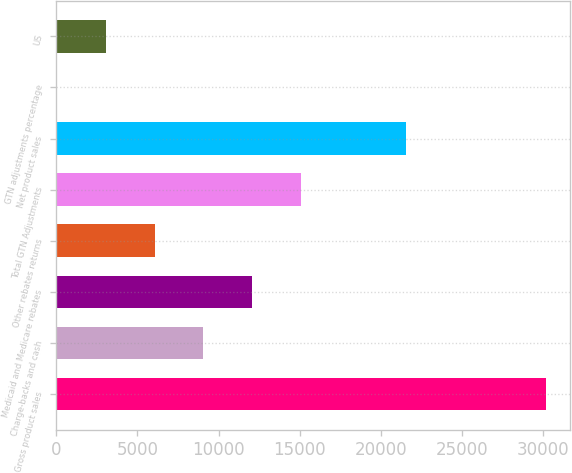Convert chart. <chart><loc_0><loc_0><loc_500><loc_500><bar_chart><fcel>Gross product sales<fcel>Charge-backs and cash<fcel>Medicaid and Medicare rebates<fcel>Other rebates returns<fcel>Total GTN Adjustments<fcel>Net product sales<fcel>GTN adjustments percentage<fcel>US<nl><fcel>30174<fcel>9071.8<fcel>12086.4<fcel>6057.2<fcel>15101<fcel>21581<fcel>28<fcel>3042.6<nl></chart> 